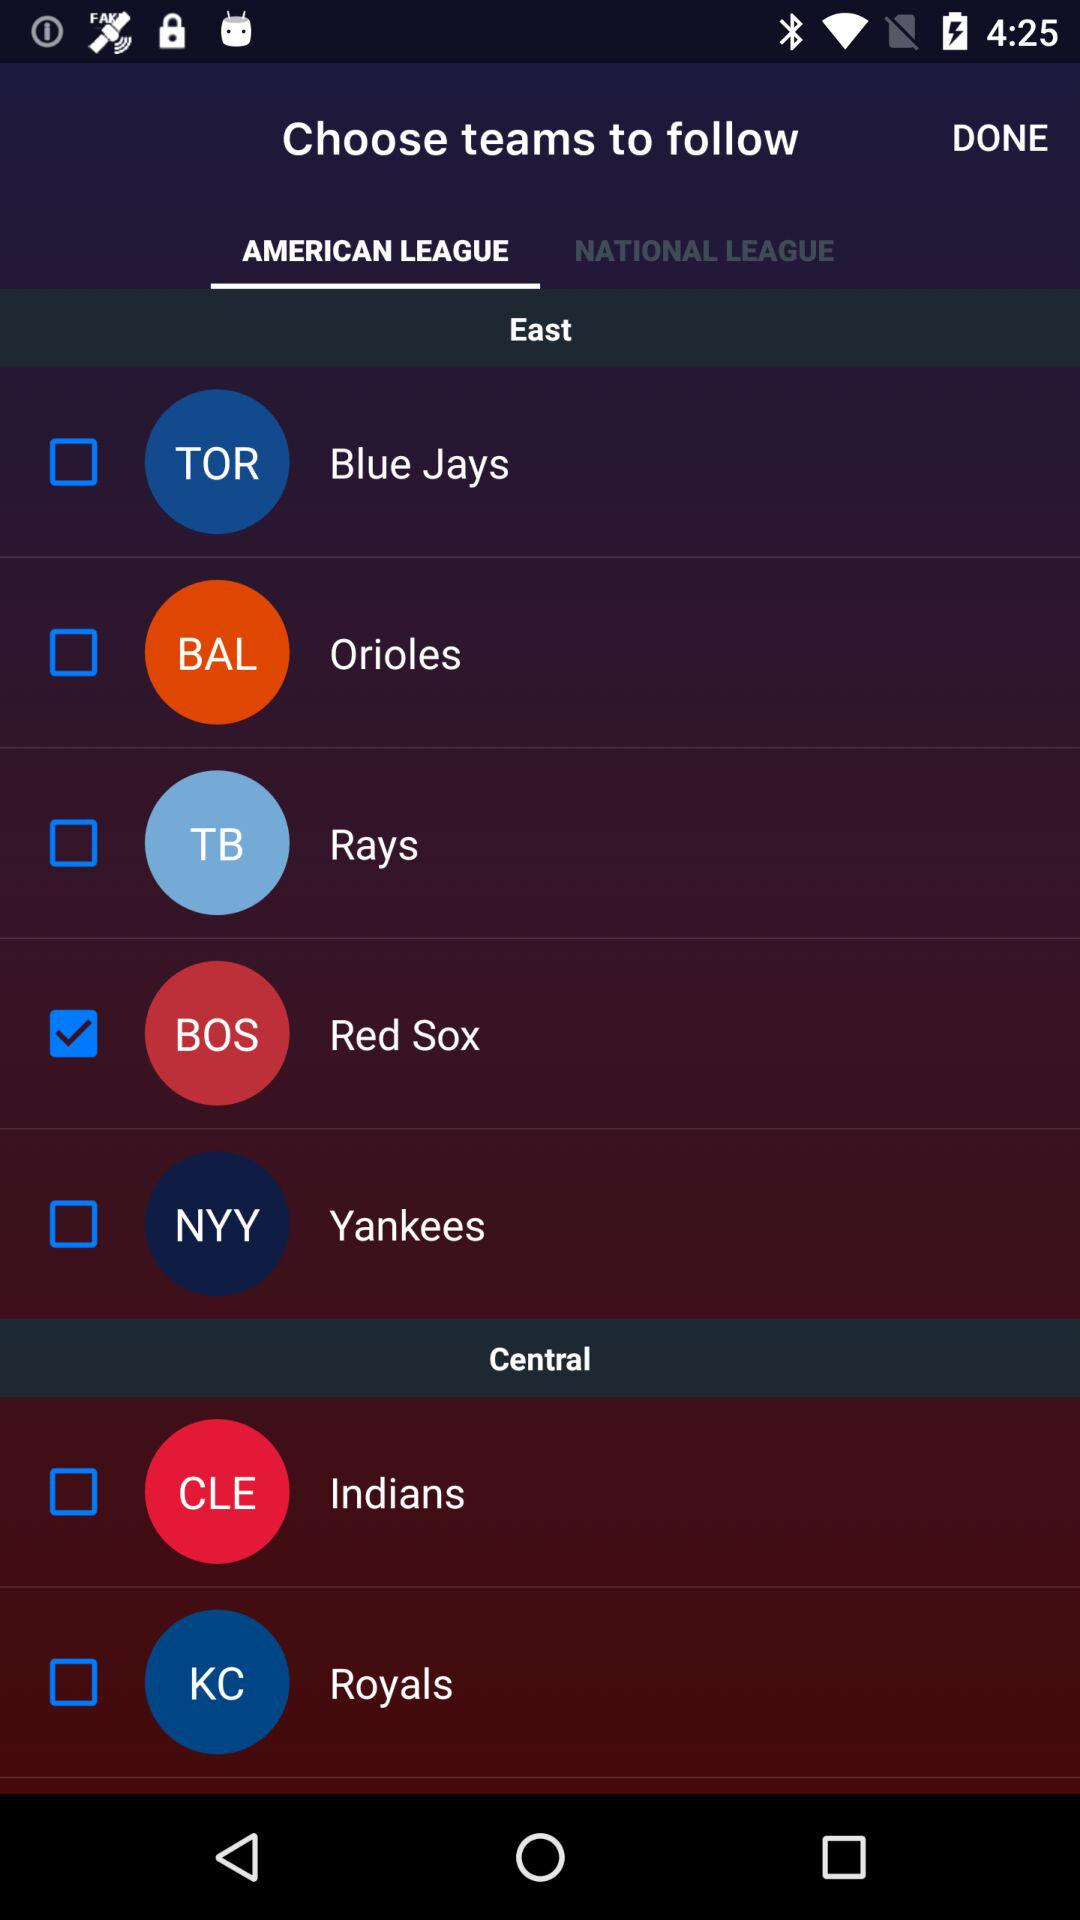Which team is selected in the "East" division? The team that is selected in the "East" division is the "Red Sox". 